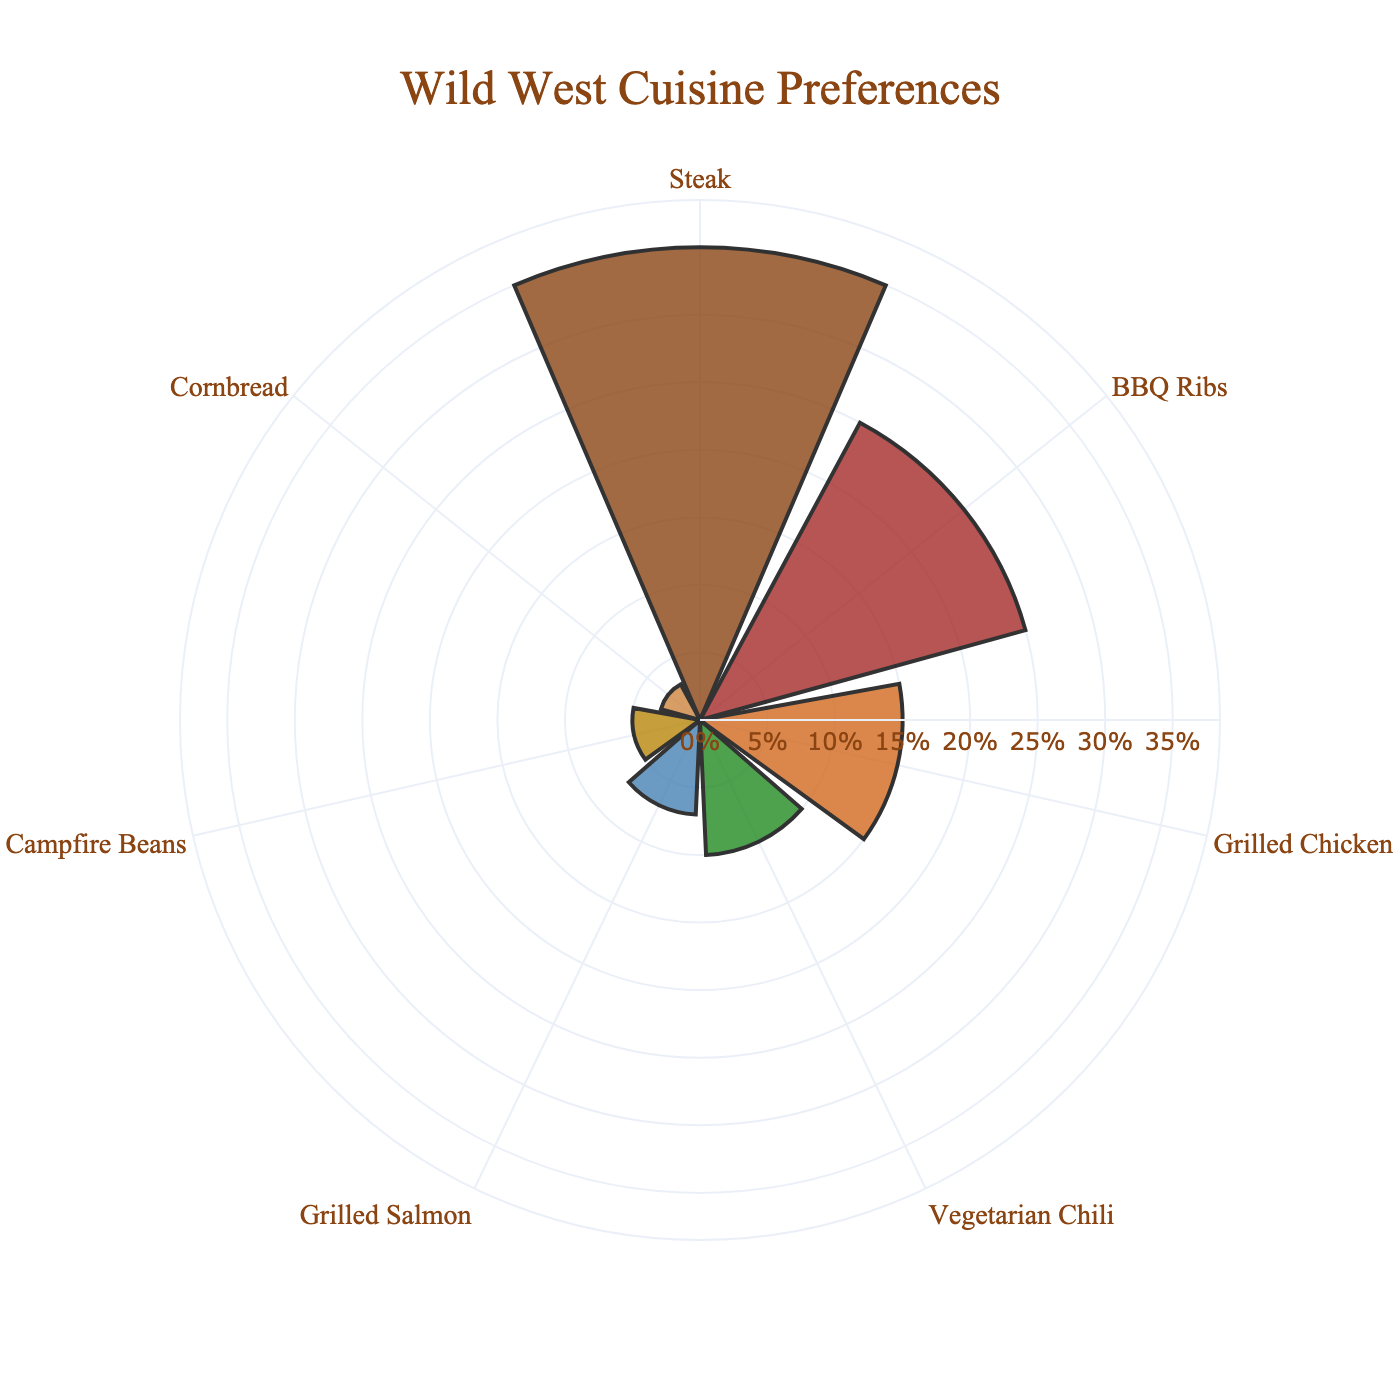What is the title of the chart? The title of the chart is located at the top center and reads, "Wild West Cuisine Preferences".
Answer: "Wild West Cuisine Preferences" What cuisine has the highest percentage preference among guests? By examining the lengths of the bars, the longest corresponds to "Steak", indicating it has the highest percentage among the listed cuisines.
Answer: Steak What is the combined percentage of preferences for Grilled Salmon and Campfire Beans? To find the combined percentage, add the percentages of Grilled Salmon (7%) and Campfire Beans (5%). 7% + 5% = 12%.
Answer: 12% How does the percentage preference for BBQ Ribs compare to that for Grilled Chicken? The bar for BBQ Ribs is longer than the one for Grilled Chicken, meaning the percentage for BBQ Ribs (25%) is greater than that for Grilled Chicken (15%).
Answer: BBQ Ribs is greater Which cuisine has the least preference among guests? The shortest bar in the chart corresponds to "Cornbread", indicating it has the lowest percentage preference at 3%.
Answer: Cornbread If you combine the preferences for Vegetarian Chili and Cornbread, what is their total percentage, and how does it compare to the percentage for Steak? The percentages for Vegetarian Chili and Cornbread are 10% and 3% respectively. Adding these, 10% + 3% = 13%. This combined percentage is less than Steak's 35%.
Answer: 13% and less than Steak What is the difference in percentage between the most and least preferred cuisines? The most preferred cuisine is Steak with 35%, and the least preferred is Cornbread with 3%. The difference is 35% - 3% = 32%.
Answer: 32% How does the preference for Grilled Chicken compare to that of Grilled Salmon? The bar for Grilled Chicken is longer than the one for Grilled Salmon, meaning the percentage for Grilled Chicken (15%) is greater than that for Grilled Salmon (7%).
Answer: Grilled Chicken is greater Which cuisines have preferences above 20%? By looking at the bars, the cuisines with preferences above 20% are "Steak" (35%) and "BBQ Ribs" (25%).
Answer: Steak and BBQ Ribs What is the average percentage of preferences for all the cuisines combined? Sum all the percentages: 35% + 25% + 15% + 10% + 7% + 5% + 3% = 100%. Divide this by the number of cuisines (7) to find the average: 100% / 7 ≈ 14.29%.
Answer: ≈14.29% 